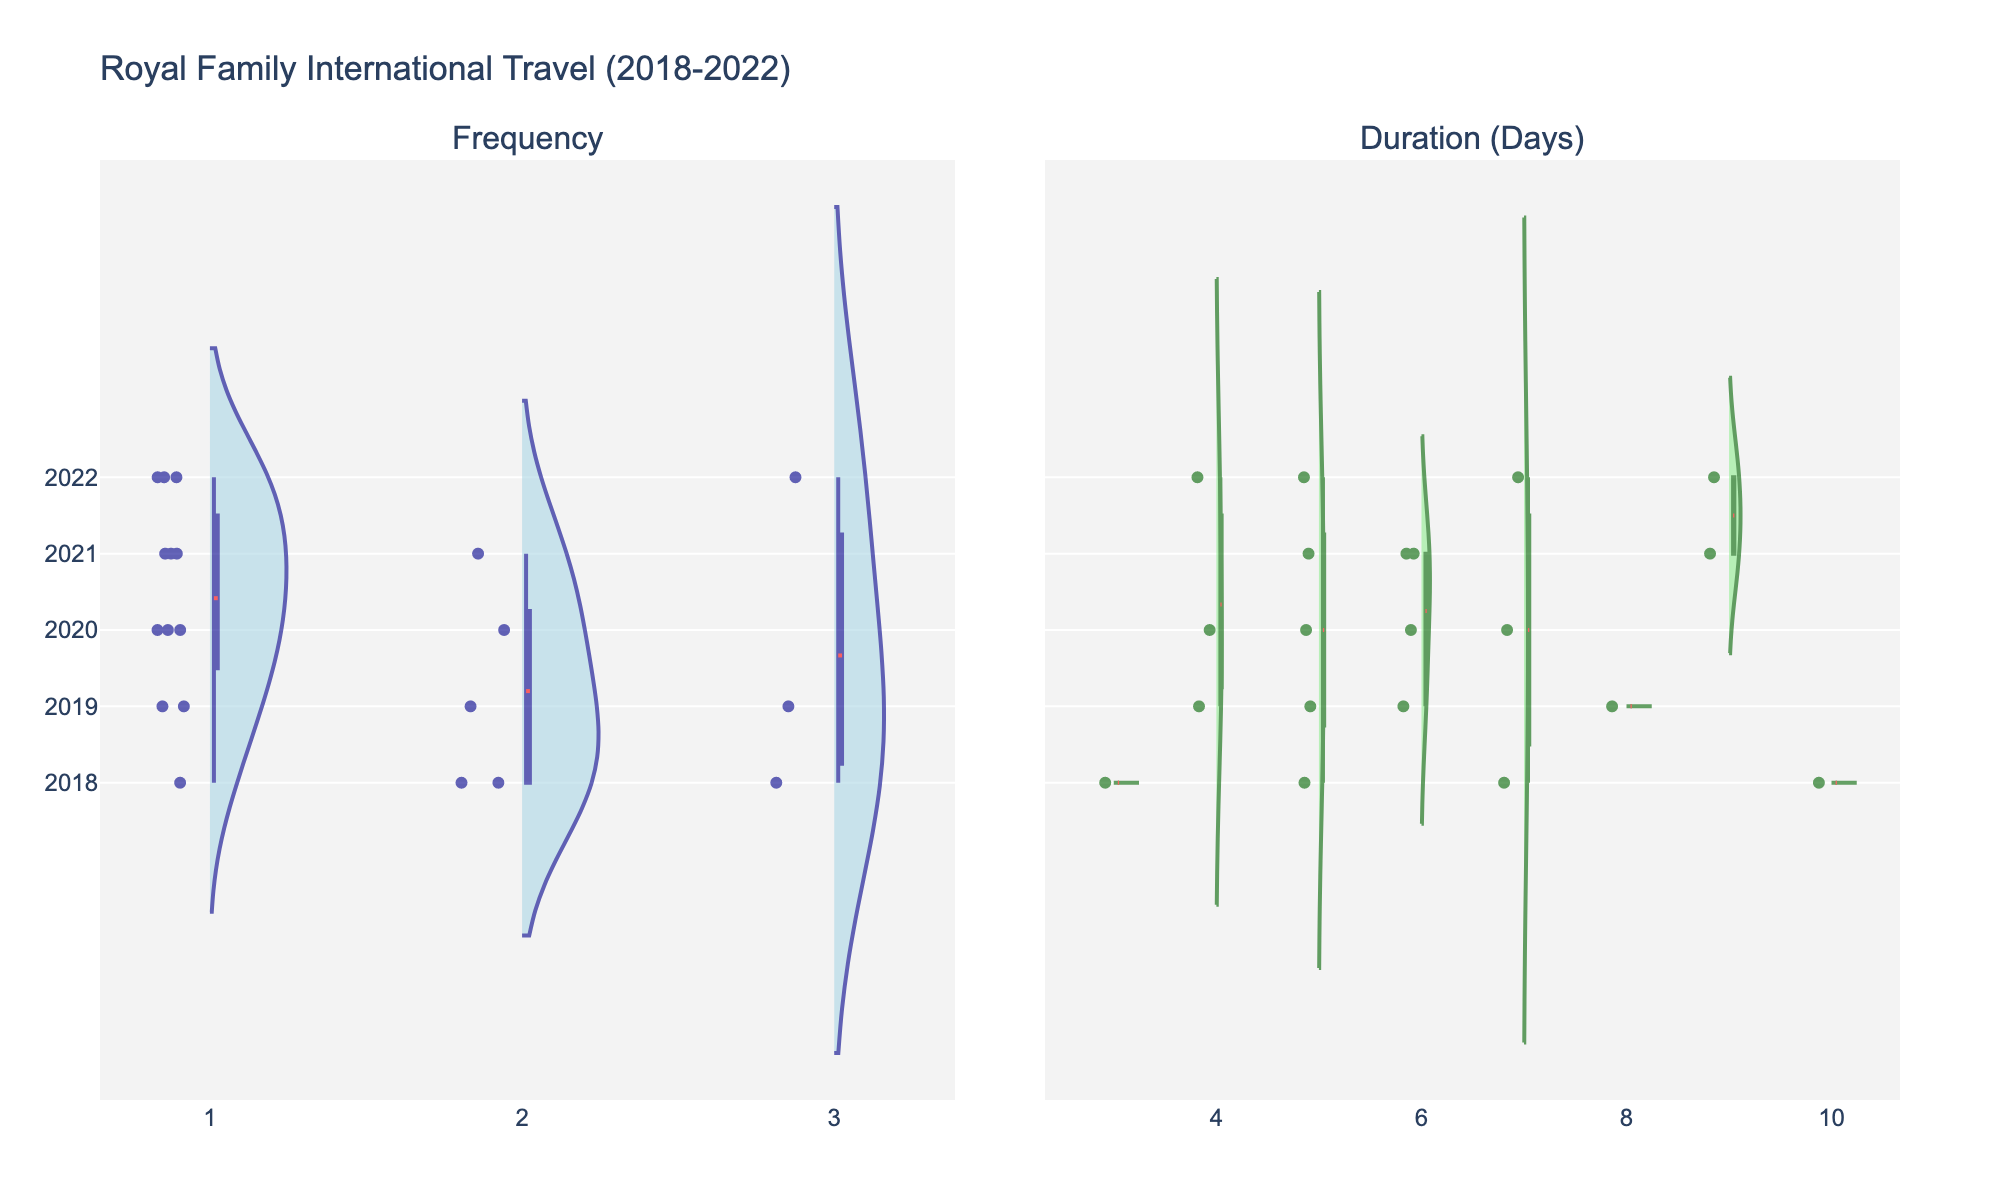What is the title of the figure? The title of the figure is displayed at the top of the plot. It provides an overview of what the figure represents. In this case, it tells us about the subject of the visualized data.
Answer: Royal Family International Travel (2018-2022) How many different years are represented in the figure? By looking at the y-axis, we can see the different years listed. Each year corresponds to a unique position along the vertical axis.
Answer: 5 Which color is used to represent the violin plot for Frequency? The color assigned to Frequency is visible by examining the violin shape on the left subplot.
Answer: Light blue In which year did the Royal Family have the highest variation in the duration of international travel days? To find the year with the highest variation in the duration, compare the width and spread of the duration violin plots across all years. The year with the widest spread represents the highest variation.
Answer: 2018 How many data points are plotted for Frequency in 2019? Data points can be counted within the Frequency violin plot for 2019 by looking at the individual points inside the violin shape.
Answer: 3 What is the median value of the Duration (Days) in 2021? The median value can be found within the box plot overlay on the violin plot for 2021 under Duration (Days). Look for the middle line within the box.
Answer: 6 Which year has the lowest mean value for the Duration (Days)? The mean value is indicated by the red line in the violin plot for each year. Identify the year where this line is closest to the bottom of the plot.
Answer: 2018 Which royal family member traveled most frequently in 2018? Identify the frequency values indicated by positions in the violin plot for Frequency in 2018 and correlate them with the royal family members.
Answer: Prince William By what margin is the mean duration of travel higher in 2021 compared to 2022? First, locate the mean duration values indicated by the red lines for both 2021 and 2022. Then, calculate the difference between these two mean values.
Answer: 1 day How does the travel frequency in 2020 compare to 2022? Visually compare the positions and spread of the Frequency violins for 2020 and 2022 to determine if one year generally had higher frequencies than the other.
Answer: Higher in 2022 